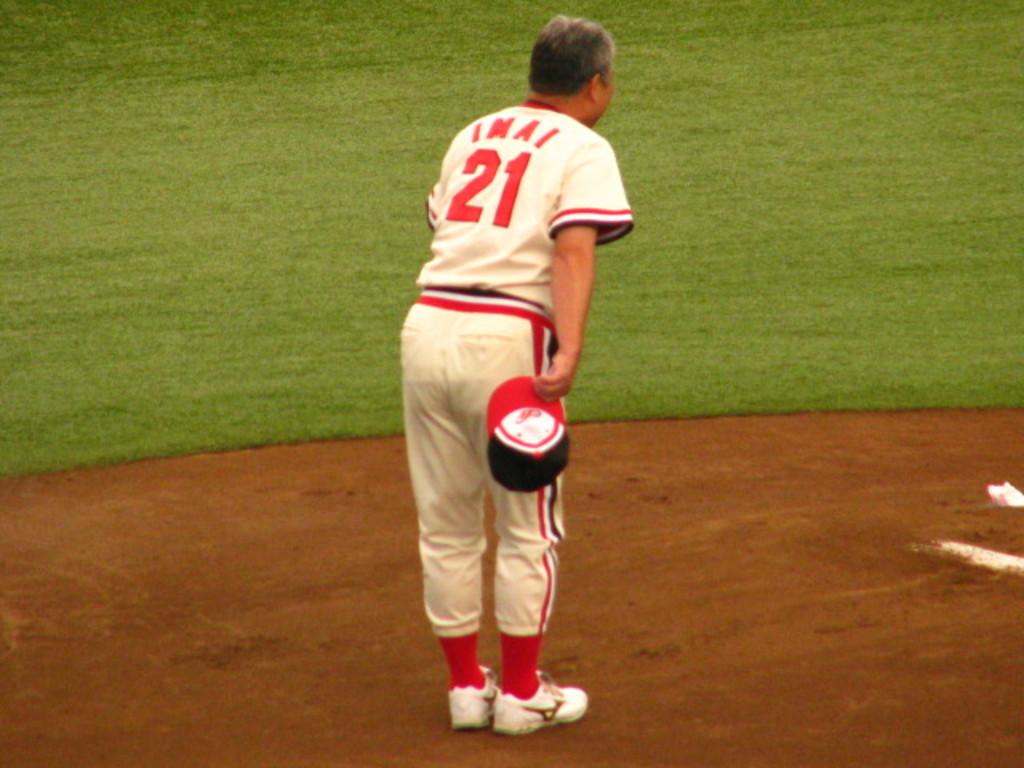What number is on the jersey?
Give a very brief answer. 21. 